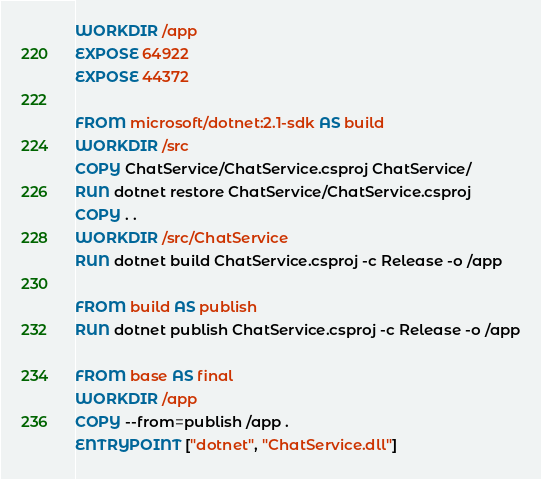<code> <loc_0><loc_0><loc_500><loc_500><_Dockerfile_>WORKDIR /app
EXPOSE 64922
EXPOSE 44372

FROM microsoft/dotnet:2.1-sdk AS build
WORKDIR /src
COPY ChatService/ChatService.csproj ChatService/
RUN dotnet restore ChatService/ChatService.csproj
COPY . .
WORKDIR /src/ChatService
RUN dotnet build ChatService.csproj -c Release -o /app

FROM build AS publish
RUN dotnet publish ChatService.csproj -c Release -o /app

FROM base AS final
WORKDIR /app
COPY --from=publish /app .
ENTRYPOINT ["dotnet", "ChatService.dll"]
</code> 